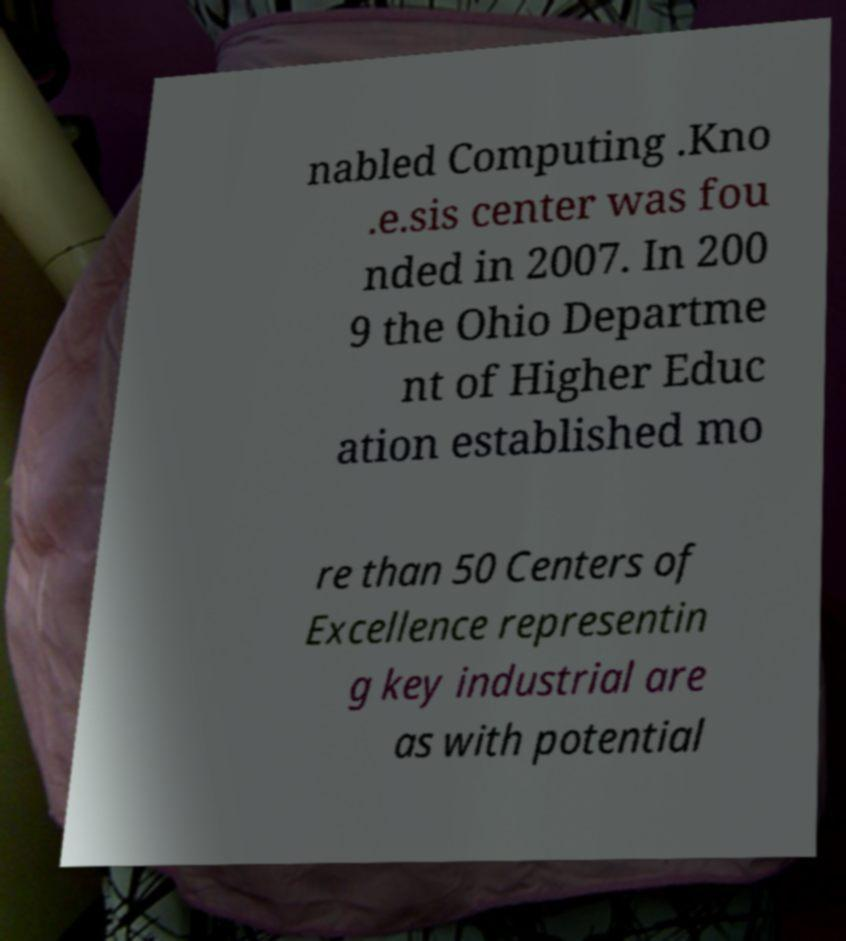Could you extract and type out the text from this image? nabled Computing .Kno .e.sis center was fou nded in 2007. In 200 9 the Ohio Departme nt of Higher Educ ation established mo re than 50 Centers of Excellence representin g key industrial are as with potential 